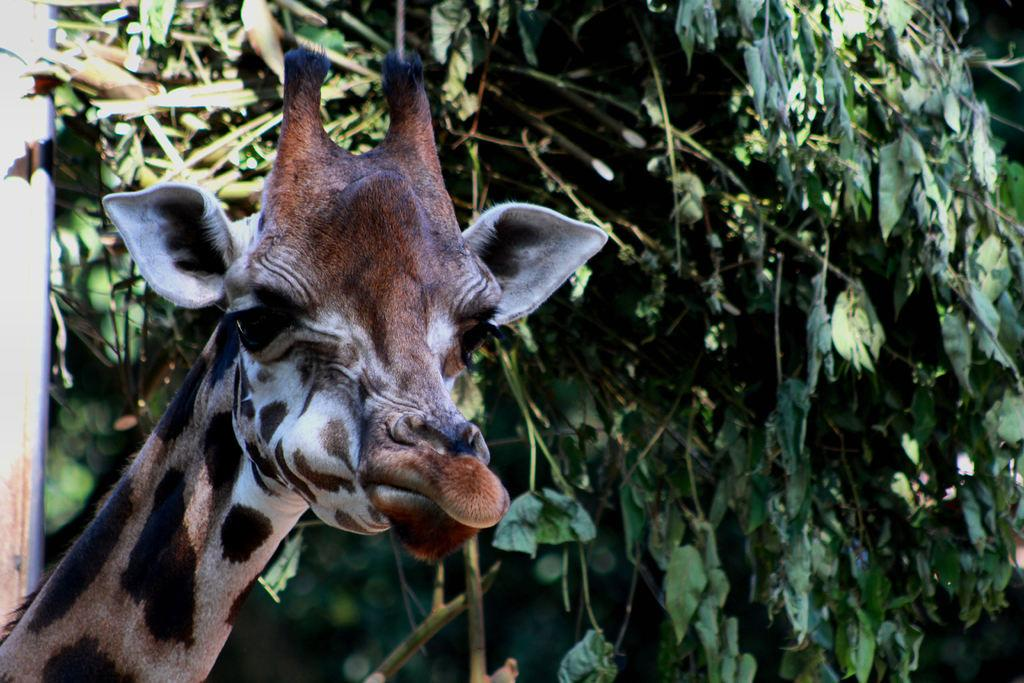What animal is the main subject of the image? There is a giraffe in the image. Where is the giraffe located in the image? The giraffe is in the front of the image. What type of vegetation can be seen in the background of the image? There are green color leaves in the background of the image. Can you see your aunt standing next to the giraffe in the image? There is no aunt present in the image; it only features a giraffe. What type of seed can be seen growing on the leaves in the background of the image? There are no seeds visible in the image; it only shows green leaves in the background. 